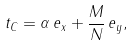<formula> <loc_0><loc_0><loc_500><loc_500>t _ { C } = \alpha \, e _ { x } + \frac { M } { N } \, e _ { y } ,</formula> 